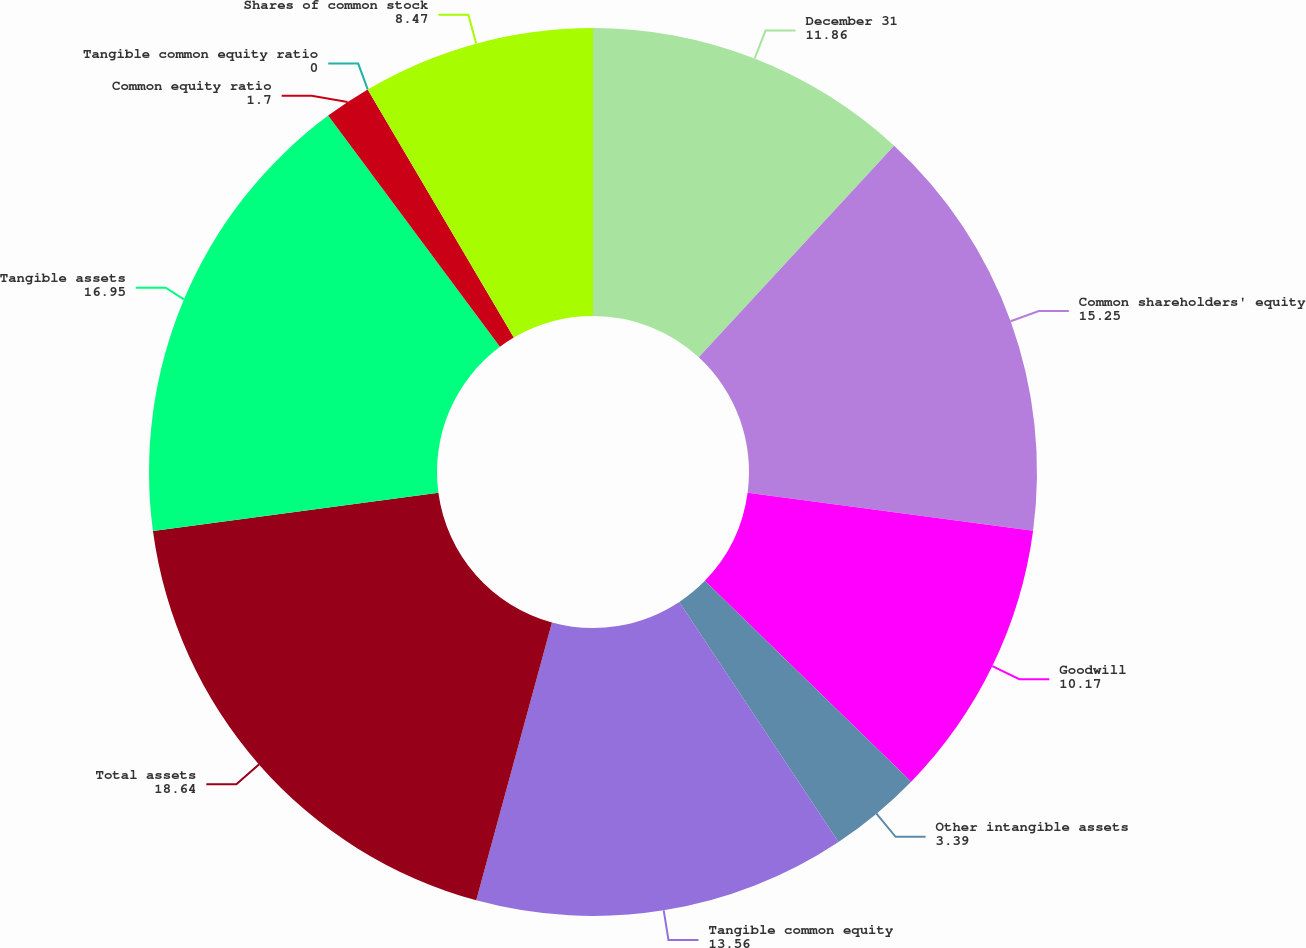Convert chart. <chart><loc_0><loc_0><loc_500><loc_500><pie_chart><fcel>December 31<fcel>Common shareholders' equity<fcel>Goodwill<fcel>Other intangible assets<fcel>Tangible common equity<fcel>Total assets<fcel>Tangible assets<fcel>Common equity ratio<fcel>Tangible common equity ratio<fcel>Shares of common stock<nl><fcel>11.86%<fcel>15.25%<fcel>10.17%<fcel>3.39%<fcel>13.56%<fcel>18.64%<fcel>16.95%<fcel>1.7%<fcel>0.0%<fcel>8.47%<nl></chart> 